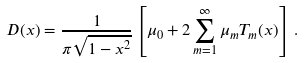<formula> <loc_0><loc_0><loc_500><loc_500>D ( x ) = \frac { 1 } { \pi \sqrt { 1 - x ^ { 2 } } } \left [ \mu _ { 0 } + 2 \sum _ { m = 1 } ^ { \infty } \mu _ { m } T _ { m } ( x ) \right ] \, .</formula> 